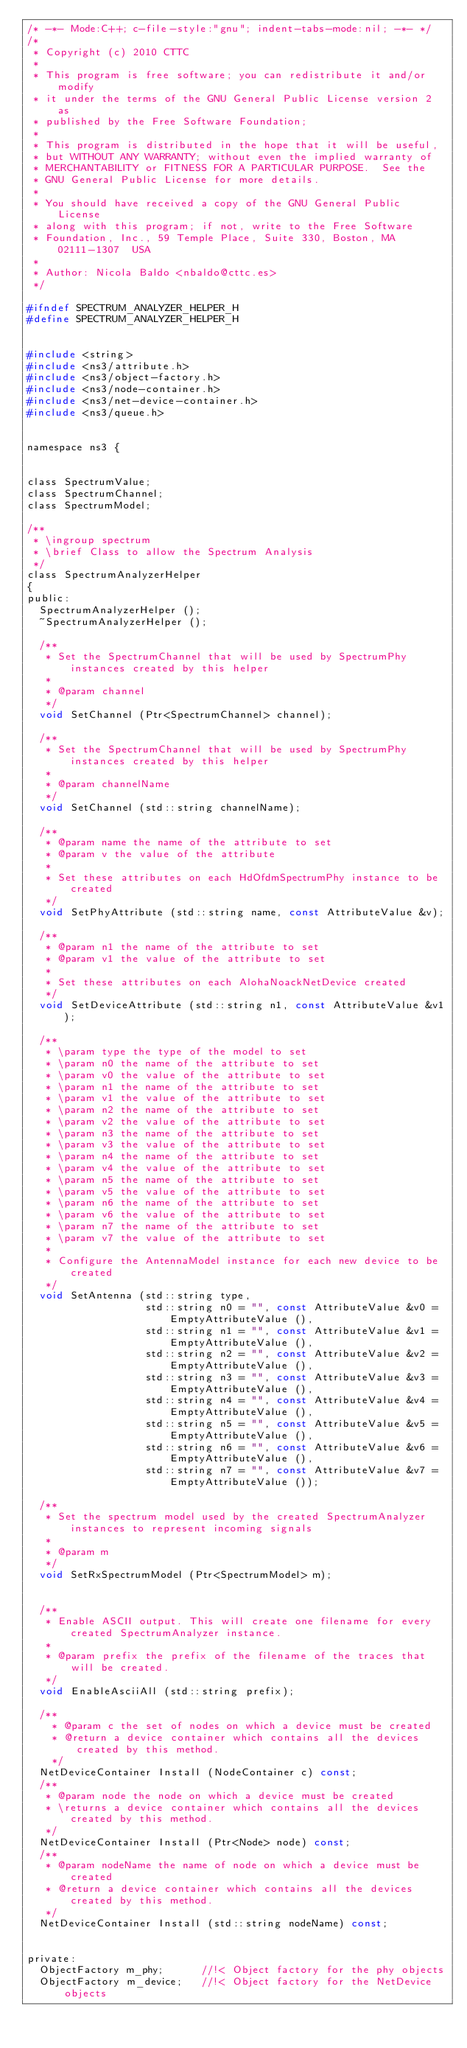<code> <loc_0><loc_0><loc_500><loc_500><_C_>/* -*- Mode:C++; c-file-style:"gnu"; indent-tabs-mode:nil; -*- */
/*
 * Copyright (c) 2010 CTTC
 *
 * This program is free software; you can redistribute it and/or modify
 * it under the terms of the GNU General Public License version 2 as
 * published by the Free Software Foundation;
 *
 * This program is distributed in the hope that it will be useful,
 * but WITHOUT ANY WARRANTY; without even the implied warranty of
 * MERCHANTABILITY or FITNESS FOR A PARTICULAR PURPOSE.  See the
 * GNU General Public License for more details.
 *
 * You should have received a copy of the GNU General Public License
 * along with this program; if not, write to the Free Software
 * Foundation, Inc., 59 Temple Place, Suite 330, Boston, MA  02111-1307  USA
 *
 * Author: Nicola Baldo <nbaldo@cttc.es>
 */

#ifndef SPECTRUM_ANALYZER_HELPER_H
#define SPECTRUM_ANALYZER_HELPER_H


#include <string>
#include <ns3/attribute.h>
#include <ns3/object-factory.h>
#include <ns3/node-container.h>
#include <ns3/net-device-container.h>
#include <ns3/queue.h>


namespace ns3 {


class SpectrumValue;
class SpectrumChannel;
class SpectrumModel;

/**
 * \ingroup spectrum
 * \brief Class to allow the Spectrum Analysis
 */
class SpectrumAnalyzerHelper
{
public:
  SpectrumAnalyzerHelper ();
  ~SpectrumAnalyzerHelper ();

  /**
   * Set the SpectrumChannel that will be used by SpectrumPhy instances created by this helper
   *
   * @param channel
   */
  void SetChannel (Ptr<SpectrumChannel> channel);

  /**
   * Set the SpectrumChannel that will be used by SpectrumPhy instances created by this helper
   *
   * @param channelName
   */
  void SetChannel (std::string channelName);

  /**
   * @param name the name of the attribute to set
   * @param v the value of the attribute
   *
   * Set these attributes on each HdOfdmSpectrumPhy instance to be created
   */
  void SetPhyAttribute (std::string name, const AttributeValue &v);

  /**
   * @param n1 the name of the attribute to set
   * @param v1 the value of the attribute to set
   *
   * Set these attributes on each AlohaNoackNetDevice created
   */
  void SetDeviceAttribute (std::string n1, const AttributeValue &v1);

  /**
   * \param type the type of the model to set
   * \param n0 the name of the attribute to set
   * \param v0 the value of the attribute to set
   * \param n1 the name of the attribute to set
   * \param v1 the value of the attribute to set
   * \param n2 the name of the attribute to set
   * \param v2 the value of the attribute to set
   * \param n3 the name of the attribute to set
   * \param v3 the value of the attribute to set
   * \param n4 the name of the attribute to set
   * \param v4 the value of the attribute to set
   * \param n5 the name of the attribute to set
   * \param v5 the value of the attribute to set
   * \param n6 the name of the attribute to set
   * \param v6 the value of the attribute to set
   * \param n7 the name of the attribute to set
   * \param v7 the value of the attribute to set
   *
   * Configure the AntennaModel instance for each new device to be created
   */
  void SetAntenna (std::string type,
                   std::string n0 = "", const AttributeValue &v0 = EmptyAttributeValue (),
                   std::string n1 = "", const AttributeValue &v1 = EmptyAttributeValue (),
                   std::string n2 = "", const AttributeValue &v2 = EmptyAttributeValue (),
                   std::string n3 = "", const AttributeValue &v3 = EmptyAttributeValue (),
                   std::string n4 = "", const AttributeValue &v4 = EmptyAttributeValue (),
                   std::string n5 = "", const AttributeValue &v5 = EmptyAttributeValue (),
                   std::string n6 = "", const AttributeValue &v6 = EmptyAttributeValue (),
                   std::string n7 = "", const AttributeValue &v7 = EmptyAttributeValue ());

  /**
   * Set the spectrum model used by the created SpectrumAnalyzer instances to represent incoming signals
   *
   * @param m 
   */
  void SetRxSpectrumModel (Ptr<SpectrumModel> m);


  /** 
   * Enable ASCII output. This will create one filename for every created SpectrumAnalyzer instance.
   * 
   * @param prefix the prefix of the filename of the traces that will be created.
   */
  void EnableAsciiAll (std::string prefix);

  /**
    * @param c the set of nodes on which a device must be created
    * @return a device container which contains all the devices created by this method.
    */
  NetDeviceContainer Install (NodeContainer c) const;
  /**
   * @param node the node on which a device must be created
   * \returns a device container which contains all the devices created by this method.
   */
  NetDeviceContainer Install (Ptr<Node> node) const;
  /**
   * @param nodeName the name of node on which a device must be created
   * @return a device container which contains all the devices created by this method.
   */
  NetDeviceContainer Install (std::string nodeName) const;


private:
  ObjectFactory m_phy;      //!< Object factory for the phy objects
  ObjectFactory m_device;   //!< Object factory for the NetDevice objects</code> 